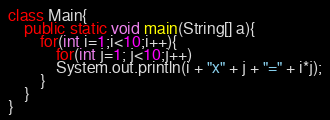<code> <loc_0><loc_0><loc_500><loc_500><_Java_>class Main{
    public static void main(String[] a){
		for(int i=1;i<10;i++){
			for(int j=1; j<10;j++)
			System.out.println(i + "x" + j + "=" + i*j);
		}
    }
}</code> 